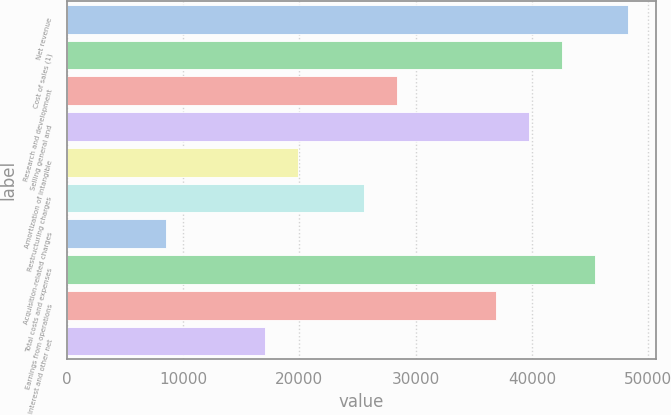<chart> <loc_0><loc_0><loc_500><loc_500><bar_chart><fcel>Net revenue<fcel>Cost of sales (1)<fcel>Research and development<fcel>Selling general and<fcel>Amortization of intangible<fcel>Restructuring charges<fcel>Acquisition-related charges<fcel>Total costs and expenses<fcel>Earnings from operations<fcel>Interest and other net<nl><fcel>48290<fcel>42608.9<fcel>28406<fcel>39768.3<fcel>19884.2<fcel>25565.4<fcel>8521.9<fcel>45449.4<fcel>36927.7<fcel>17043.6<nl></chart> 